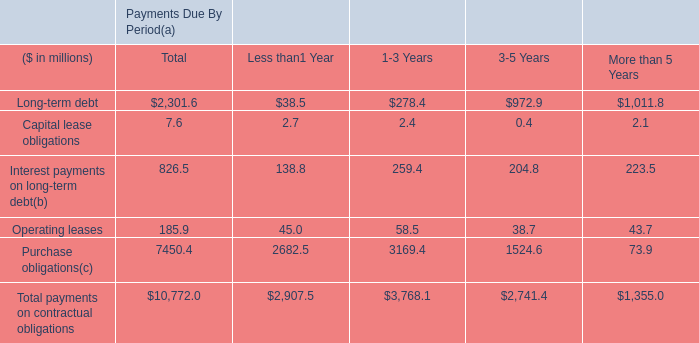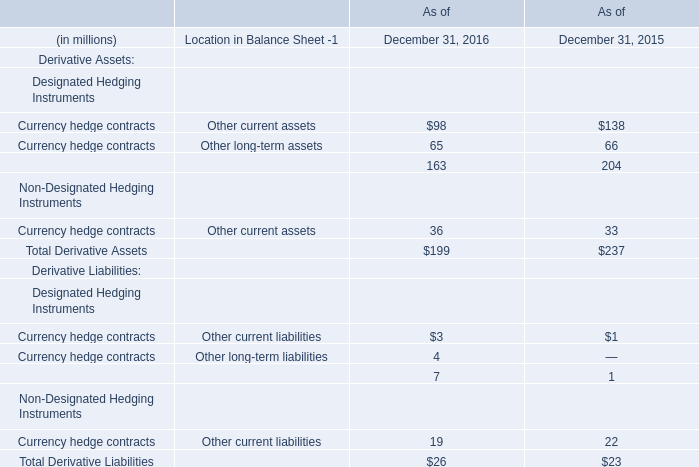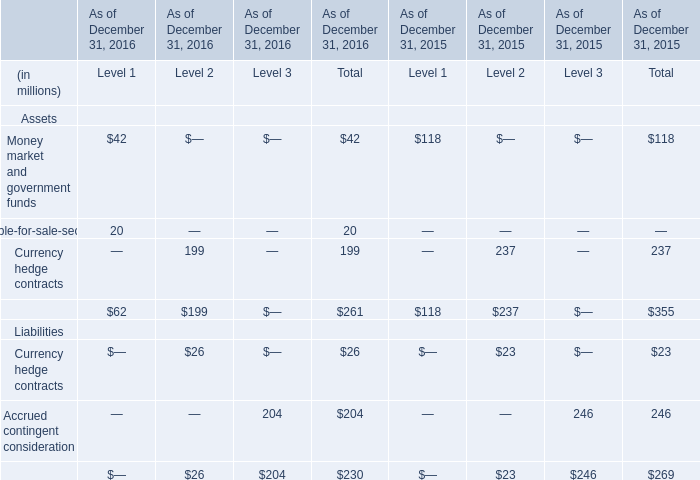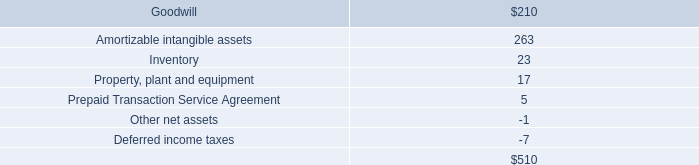what is the percentage reduction in the spending on the share repurchase program in 2006 compared to 2005?\\n 
Computations: ((358.1 - 45.7) / 358.1)
Answer: 0.87238. 